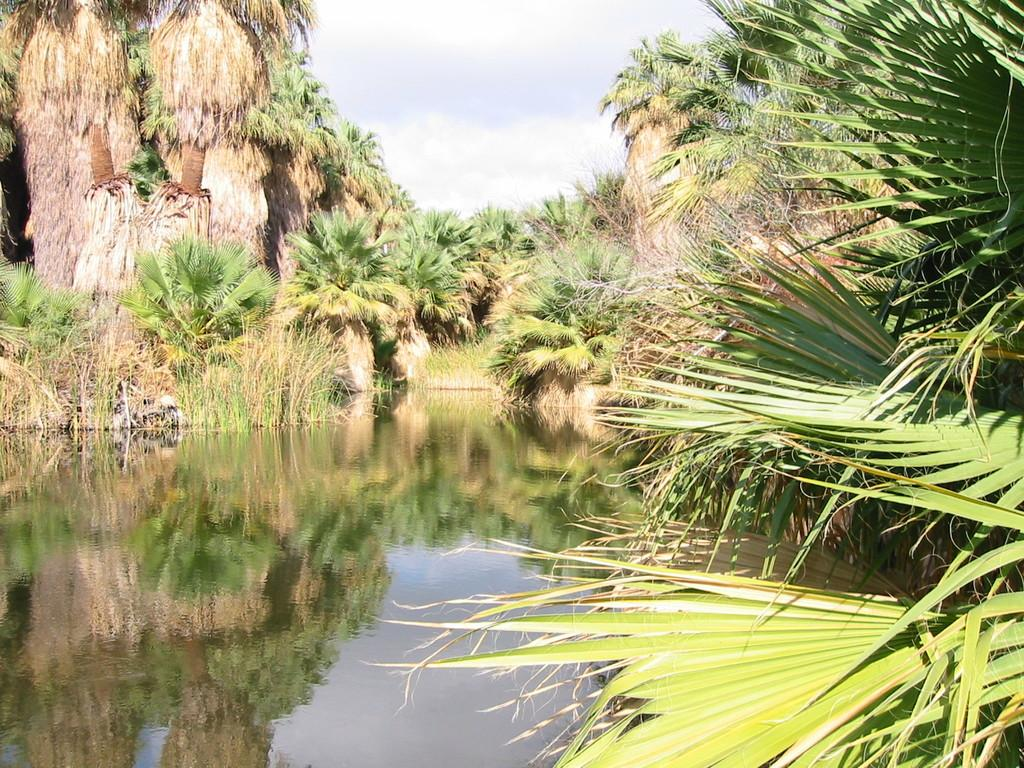What type of vegetation can be seen in the image? There are many trees and plants in the image. What is present at the bottom of the image? There is water at the bottom of the image. What can be seen in the sky at the top of the image? There are clouds in the sky at the top of the image. Can you tell me how many balloons are floating above the trees in the image? There are no balloons present in the image; it only features trees, plants, water, and clouds. What type of shop can be seen in the image? There is no shop present in the image; it is a natural scene with trees, plants, water, and clouds. 